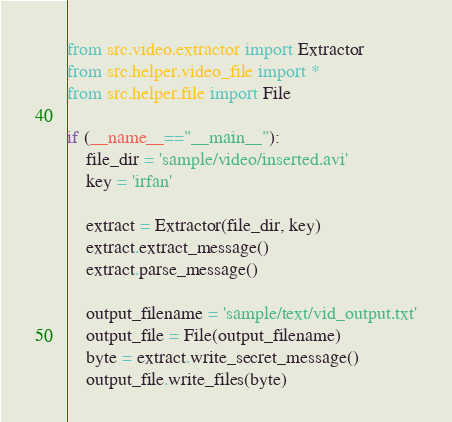<code> <loc_0><loc_0><loc_500><loc_500><_Python_>from src.video.extractor import Extractor
from src.helper.video_file import *
from src.helper.file import File

if (__name__=="__main__"):
    file_dir = 'sample/video/inserted.avi'
    key = 'irfan'

    extract = Extractor(file_dir, key)
    extract.extract_message()
    extract.parse_message()

    output_filename = 'sample/text/vid_output.txt'
    output_file = File(output_filename)
    byte = extract.write_secret_message()
    output_file.write_files(byte)</code> 